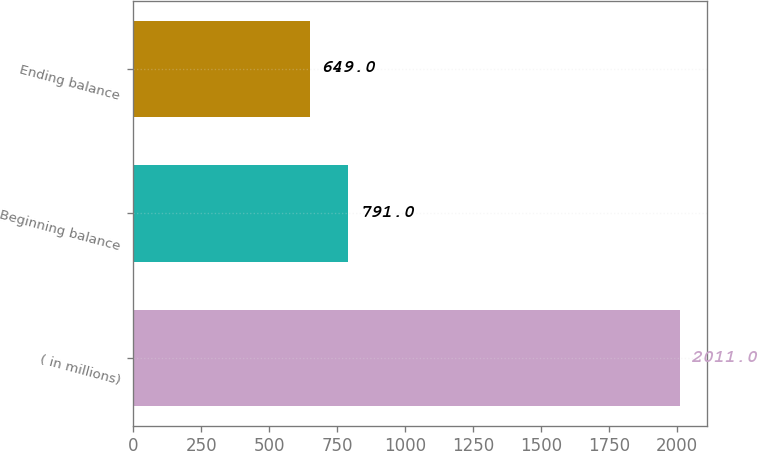Convert chart. <chart><loc_0><loc_0><loc_500><loc_500><bar_chart><fcel>( in millions)<fcel>Beginning balance<fcel>Ending balance<nl><fcel>2011<fcel>791<fcel>649<nl></chart> 